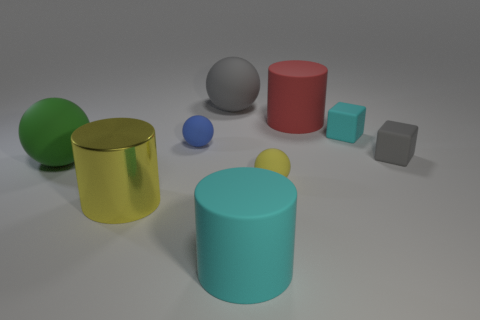Can you describe the texture and colors of the objects in the image? Certainly! The image features objects with matte textures. Regarding colors, we have a green cylinder, a red cylinder, a gray sphere, a blue sphere, a yellow cylinder with a smaller sphere on top, a cyan cylinder, and two cubes, one cyan and one gray. 